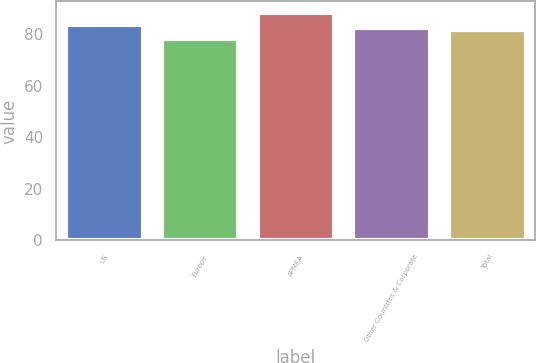<chart> <loc_0><loc_0><loc_500><loc_500><bar_chart><fcel>US<fcel>Europe<fcel>APMEA<fcel>Other Countries & Corporate<fcel>Total<nl><fcel>83.54<fcel>78.1<fcel>88.3<fcel>82.52<fcel>81.5<nl></chart> 